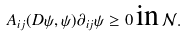Convert formula to latex. <formula><loc_0><loc_0><loc_500><loc_500>A _ { i j } ( D \psi , \psi ) \partial _ { i j } \psi \geq 0 \, \text {in} \, \mathcal { N } .</formula> 